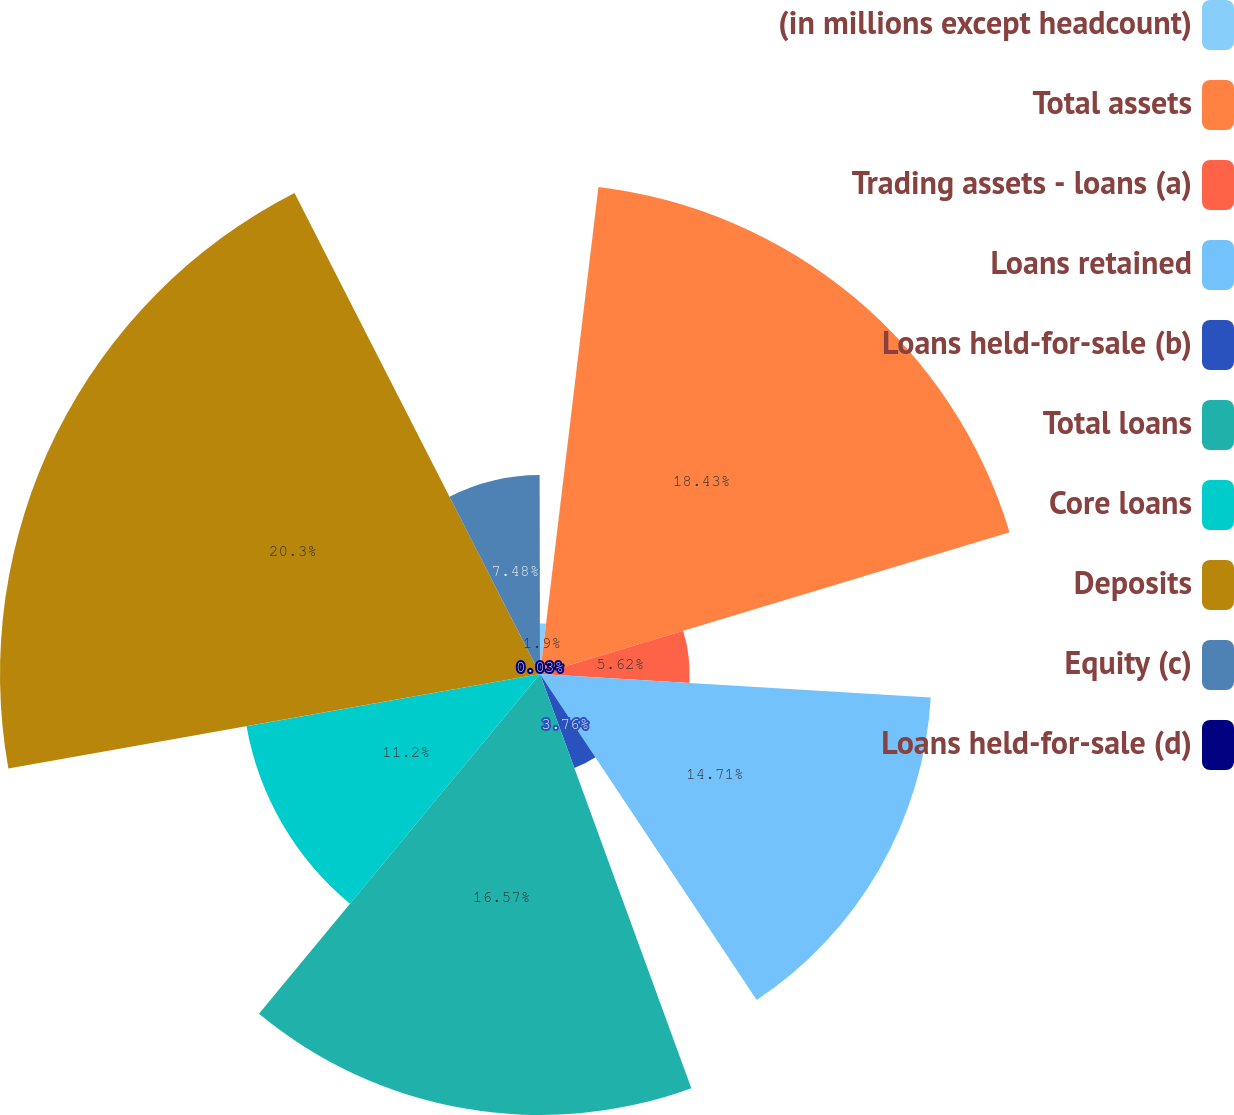<chart> <loc_0><loc_0><loc_500><loc_500><pie_chart><fcel>(in millions except headcount)<fcel>Total assets<fcel>Trading assets - loans (a)<fcel>Loans retained<fcel>Loans held-for-sale (b)<fcel>Total loans<fcel>Core loans<fcel>Deposits<fcel>Equity (c)<fcel>Loans held-for-sale (d)<nl><fcel>1.9%<fcel>18.43%<fcel>5.62%<fcel>14.71%<fcel>3.76%<fcel>16.57%<fcel>11.2%<fcel>20.29%<fcel>7.48%<fcel>0.03%<nl></chart> 